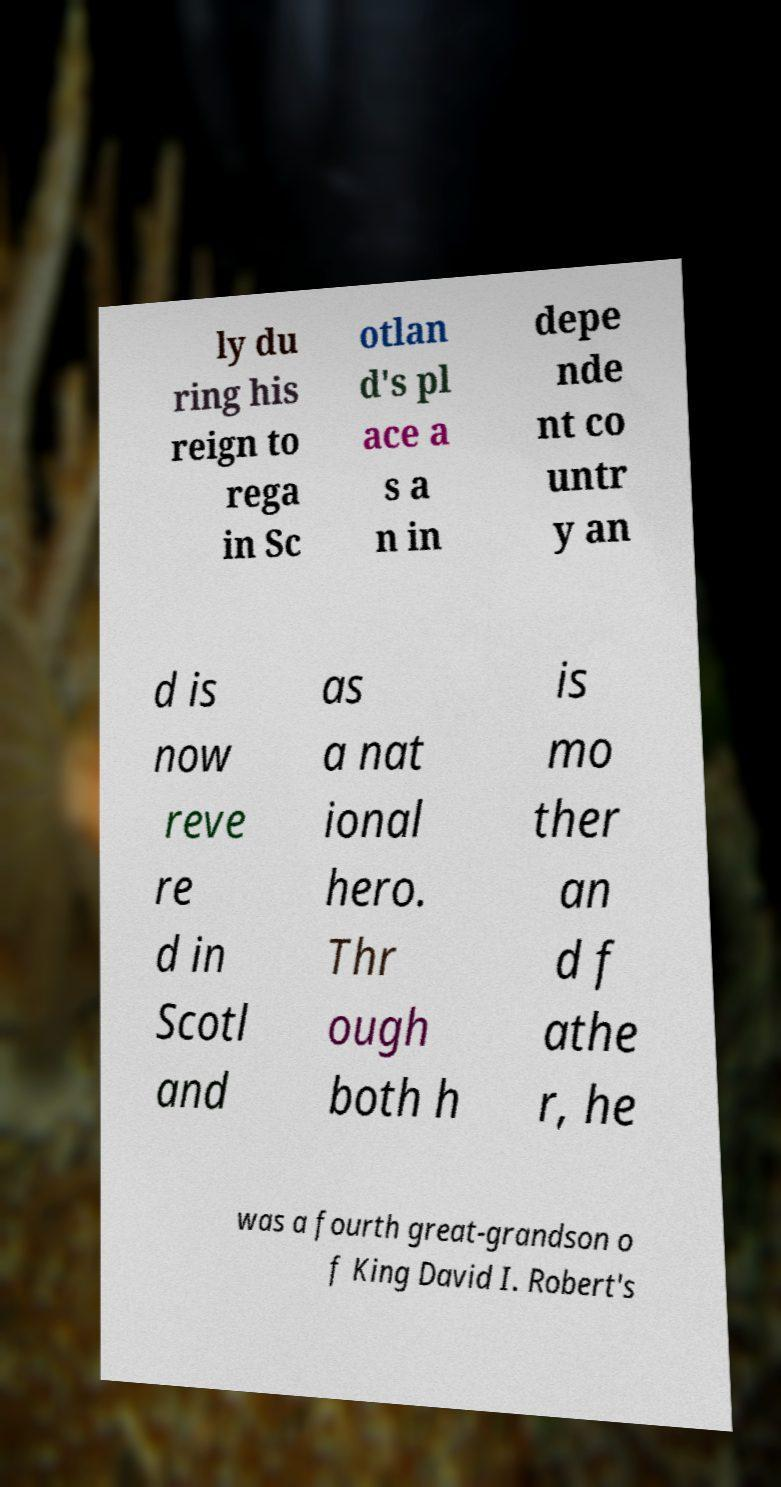For documentation purposes, I need the text within this image transcribed. Could you provide that? ly du ring his reign to rega in Sc otlan d's pl ace a s a n in depe nde nt co untr y an d is now reve re d in Scotl and as a nat ional hero. Thr ough both h is mo ther an d f athe r, he was a fourth great-grandson o f King David I. Robert's 